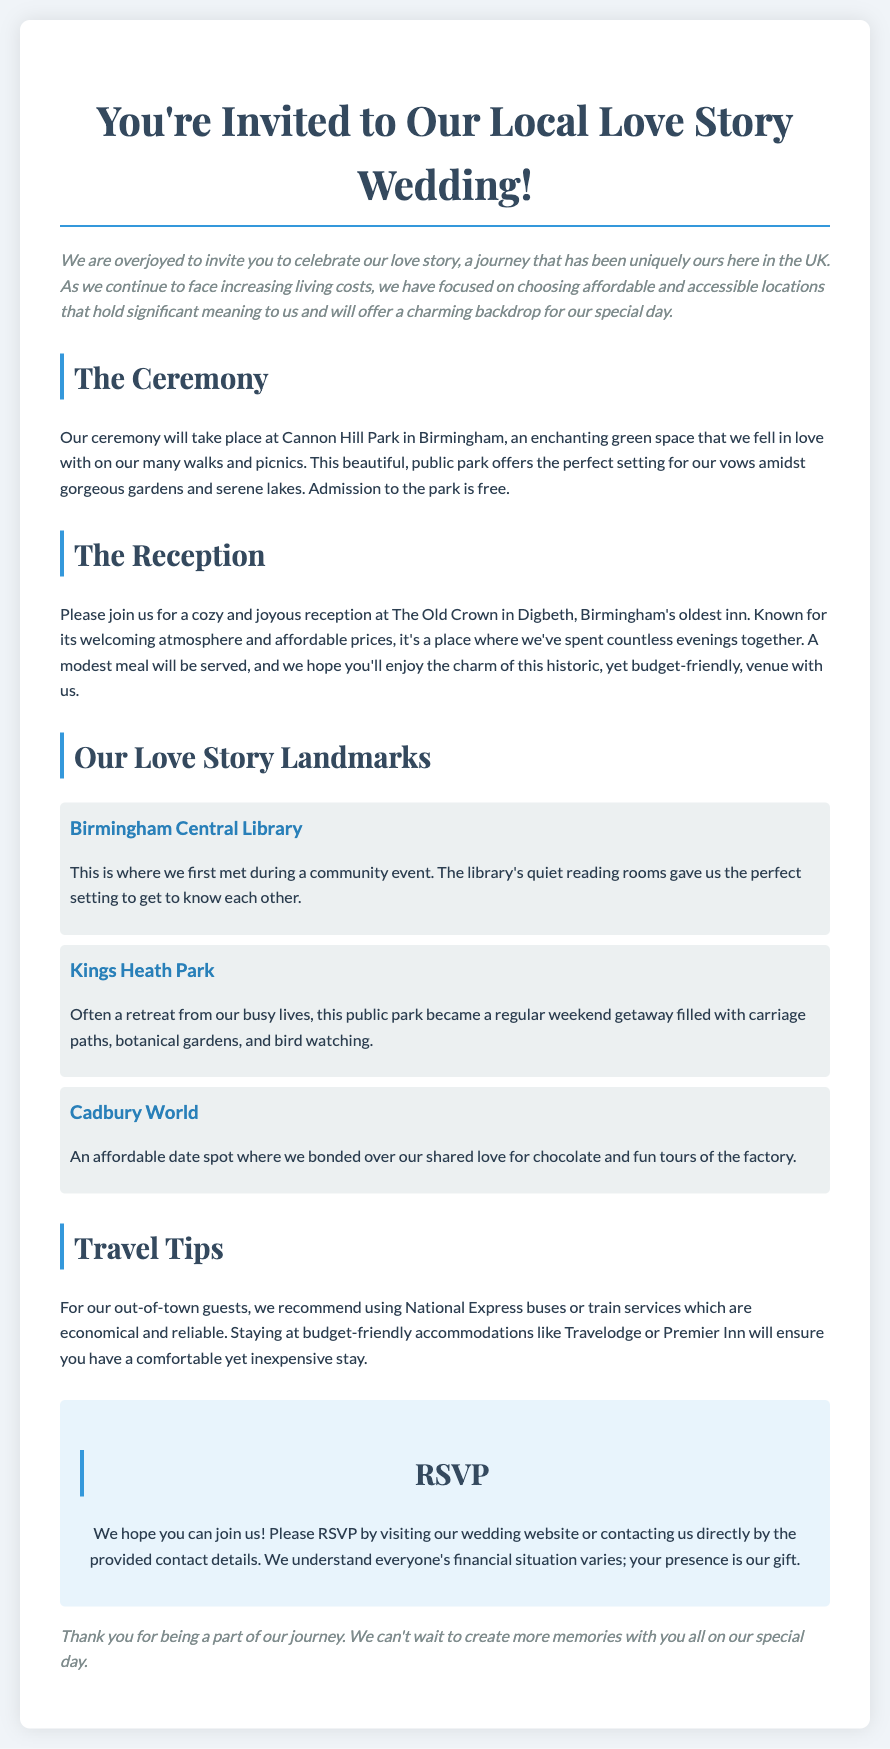What is the location of the ceremony? The ceremony will take place at Cannon Hill Park in Birmingham, which is mentioned prominently in the document.
Answer: Cannon Hill Park What is the name of the reception venue? The reception will be held at The Old Crown in Digbeth, which is specified in the reception section.
Answer: The Old Crown What is the admission fee for Cannon Hill Park? The document indicates that admission to the park is free, making it accessible for guests.
Answer: Free Where did the couple first meet? The Birmingham Central Library is mentioned as the location where the couple first met during a community event.
Answer: Birmingham Central Library What type of meal will be served at the reception? The invitation specifies that a modest meal will be served during the reception.
Answer: Modest meal What is a recommended travel option for guests? The document suggests using National Express buses or train services as economical travel options for guests.
Answer: National Express buses Which park became a regular weekend getaway for the couple? Kings Heath Park is noted as a retreat for the couple that they frequently visited on weekends.
Answer: Kings Heath Park What should guests do to RSVP? Guests are invited to RSVP by visiting the wedding website or contacting the couple directly as stated in the RSVP section.
Answer: Wedding website What is emphasized about the couple's venue choices? The document highlights that the couple has chosen affordable and accessible locations that hold significant meaning to them.
Answer: Affordable and accessible locations 